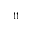Convert formula to latex. <formula><loc_0><loc_0><loc_500><loc_500>_ { 1 1 }</formula> 